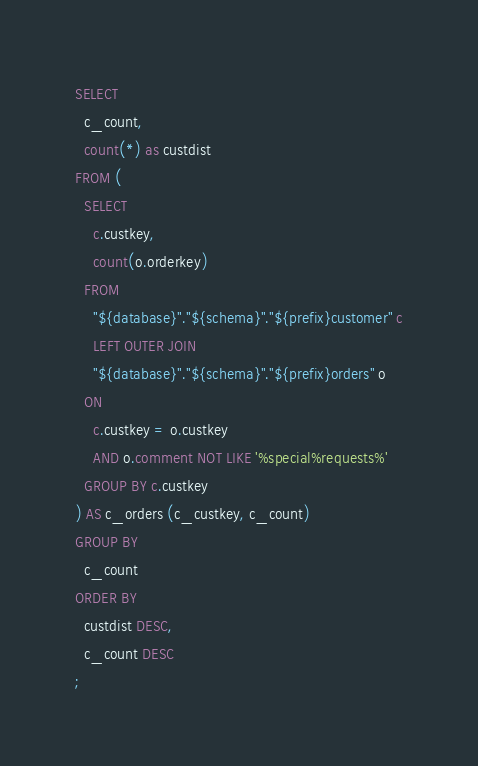Convert code to text. <code><loc_0><loc_0><loc_500><loc_500><_SQL_>SELECT 
  c_count, 
  count(*) as custdist
FROM (
  SELECT 
    c.custkey, 
    count(o.orderkey)
  FROM 
    "${database}"."${schema}"."${prefix}customer" c
    LEFT OUTER JOIN
    "${database}"."${schema}"."${prefix}orders" o
  ON 
    c.custkey = o.custkey
    AND o.comment NOT LIKE '%special%requests%'
  GROUP BY c.custkey
) AS c_orders (c_custkey, c_count)
GROUP BY 
  c_count
ORDER BY 
  custdist DESC, 
  c_count DESC
;
</code> 